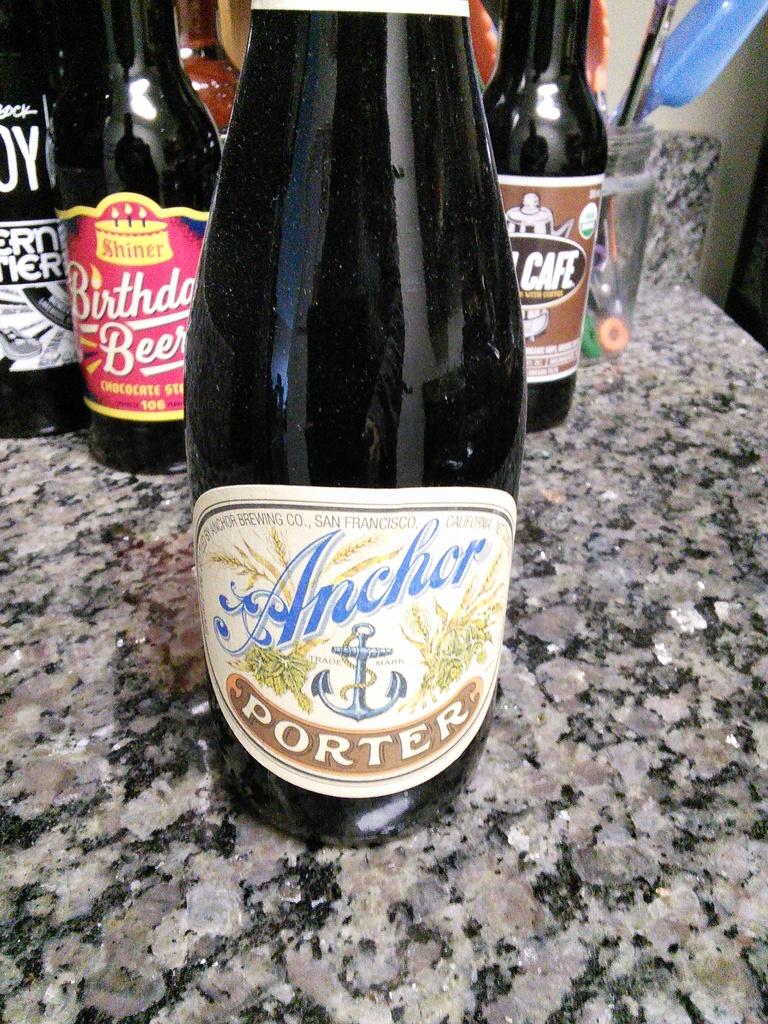What is the name of this beverage?
Your answer should be compact. Anchor porter. 